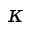<formula> <loc_0><loc_0><loc_500><loc_500>\kappa</formula> 